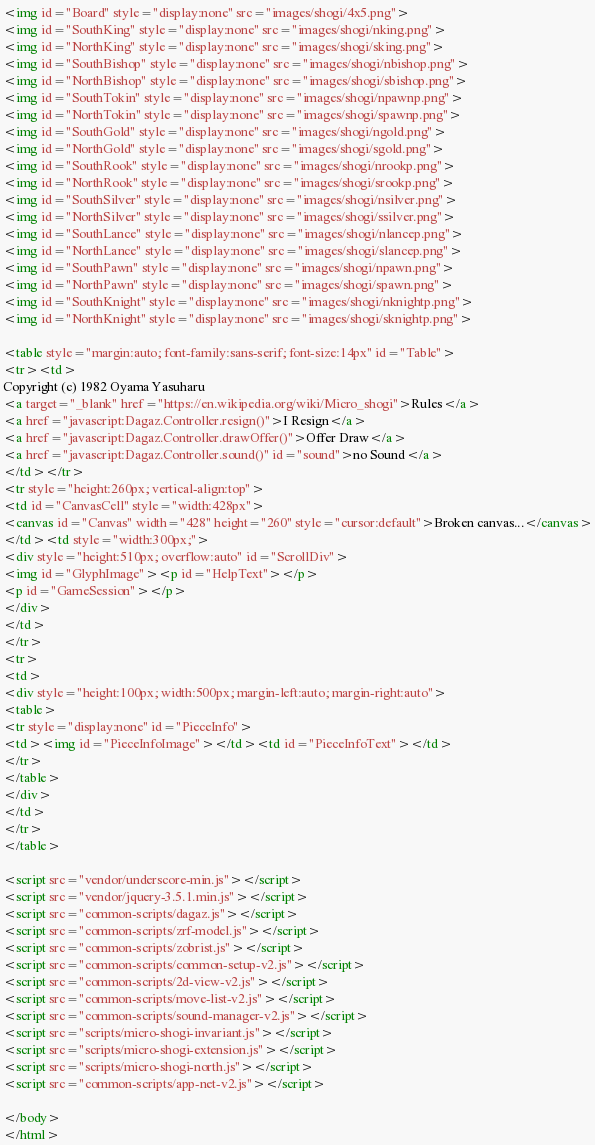<code> <loc_0><loc_0><loc_500><loc_500><_HTML_><img id="Board" style="display:none" src="images/shogi/4x5.png">
<img id="SouthKing" style="display:none" src="images/shogi/nking.png">
<img id="NorthKing" style="display:none" src="images/shogi/sking.png">
<img id="SouthBishop" style="display:none" src="images/shogi/nbishop.png">
<img id="NorthBishop" style="display:none" src="images/shogi/sbishop.png">
<img id="SouthTokin" style="display:none" src="images/shogi/npawnp.png">
<img id="NorthTokin" style="display:none" src="images/shogi/spawnp.png">
<img id="SouthGold" style="display:none" src="images/shogi/ngold.png">
<img id="NorthGold" style="display:none" src="images/shogi/sgold.png">
<img id="SouthRook" style="display:none" src="images/shogi/nrookp.png">
<img id="NorthRook" style="display:none" src="images/shogi/srookp.png">
<img id="SouthSilver" style="display:none" src="images/shogi/nsilver.png">
<img id="NorthSilver" style="display:none" src="images/shogi/ssilver.png">
<img id="SouthLance" style="display:none" src="images/shogi/nlancep.png">
<img id="NorthLance" style="display:none" src="images/shogi/slancep.png">
<img id="SouthPawn" style="display:none" src="images/shogi/npawn.png">
<img id="NorthPawn" style="display:none" src="images/shogi/spawn.png">
<img id="SouthKnight" style="display:none" src="images/shogi/nknightp.png">
<img id="NorthKnight" style="display:none" src="images/shogi/sknightp.png">

<table style="margin:auto; font-family:sans-serif; font-size:14px" id="Table">
<tr><td>
Copyright (c) 1982 Oyama Yasuharu
<a target="_blank" href="https://en.wikipedia.org/wiki/Micro_shogi">Rules</a>
<a href="javascript:Dagaz.Controller.resign()">I Resign</a>
<a href="javascript:Dagaz.Controller.drawOffer()">Offer Draw</a>
<a href="javascript:Dagaz.Controller.sound()" id="sound">no Sound</a>
</td></tr>
<tr style="height:260px; vertical-align:top">
<td id="CanvasCell" style="width:428px">
<canvas id="Canvas" width="428" height="260" style="cursor:default">Broken canvas...</canvas>
</td><td style="width:300px;">
<div style="height:510px; overflow:auto" id="ScrollDiv">
<img id="GlyphImage"><p id="HelpText"></p>
<p id="GameSession"></p>
</div>
</td>
</tr>
<tr>
<td>
<div style="height:100px; width:500px; margin-left:auto; margin-right:auto">
<table>
<tr style="display:none" id="PieceInfo">
<td><img id="PieceInfoImage"></td><td id="PieceInfoText"></td>
</tr>
</table>
</div>
</td>
</tr>
</table>

<script src="vendor/underscore-min.js"></script>
<script src="vendor/jquery-3.5.1.min.js"></script>
<script src="common-scripts/dagaz.js"></script>
<script src="common-scripts/zrf-model.js"></script>
<script src="common-scripts/zobrist.js"></script>
<script src="common-scripts/common-setup-v2.js"></script>
<script src="common-scripts/2d-view-v2.js"></script>
<script src="common-scripts/move-list-v2.js"></script>
<script src="common-scripts/sound-manager-v2.js"></script>
<script src="scripts/micro-shogi-invariant.js"></script>
<script src="scripts/micro-shogi-extension.js"></script>
<script src="scripts/micro-shogi-north.js"></script>
<script src="common-scripts/app-net-v2.js"></script>

</body>
</html>
</code> 